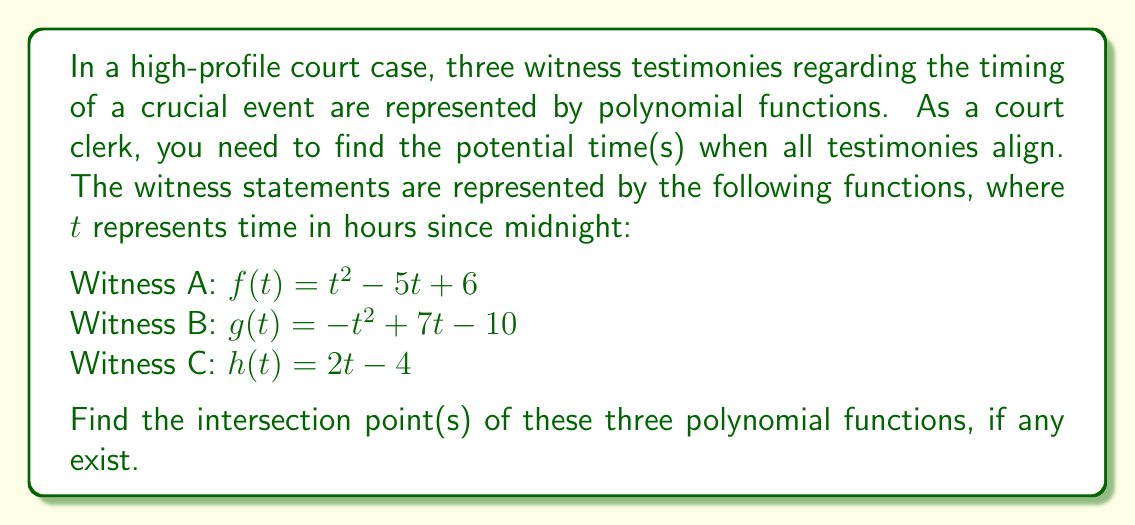Provide a solution to this math problem. To find the intersection point(s) of the three polynomial functions, we need to solve the system of equations:

$$\begin{cases}
t^2 - 5t + 6 = -t^2 + 7t - 10 \\
t^2 - 5t + 6 = 2t - 4 \\
-t^2 + 7t - 10 = 2t - 4
\end{cases}$$

Step 1: Solve $f(t) = g(t)$
$t^2 - 5t + 6 = -t^2 + 7t - 10$
$2t^2 - 12t + 16 = 0$
$2(t^2 - 6t + 8) = 0$
$2(t - 2)(t - 4) = 0$
$t = 2$ or $t = 4$

Step 2: Check if either solution satisfies $f(t) = h(t)$ and $g(t) = h(t)$

For $t = 2$:
$f(2) = 2^2 - 5(2) + 6 = 4 - 10 + 6 = 0$
$g(2) = -(2^2) + 7(2) - 10 = -4 + 14 - 10 = 0$
$h(2) = 2(2) - 4 = 0$

All functions equal 0 when $t = 2$, so this is an intersection point.

For $t = 4$:
$f(4) = 4^2 - 5(4) + 6 = 16 - 20 + 6 = 2$
$g(4) = -(4^2) + 7(4) - 10 = -16 + 28 - 10 = 2$
$h(4) = 2(4) - 4 = 4$

The functions do not all intersect at $t = 4$.

Therefore, there is only one intersection point at $t = 2$.
Answer: $(2, 0)$ 